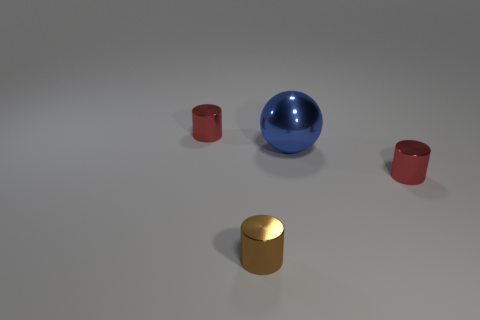Is there any other thing that is the same size as the blue metal thing?
Offer a very short reply. No. There is a blue thing behind the small shiny cylinder right of the brown thing; what is its size?
Make the answer very short. Large. Are there any tiny red shiny cylinders right of the large blue metal thing?
Your answer should be compact. Yes. Are there an equal number of red metal objects to the right of the large blue metallic thing and large blue shiny objects?
Offer a very short reply. Yes. What is the brown thing made of?
Your answer should be very brief. Metal. There is a thing that is both on the right side of the brown cylinder and in front of the big blue metallic ball; what color is it?
Make the answer very short. Red. Are there an equal number of red metal objects on the right side of the tiny brown shiny thing and brown objects in front of the large blue thing?
Offer a terse response. Yes. There is another large object that is made of the same material as the brown object; what color is it?
Keep it short and to the point. Blue. There is a red thing that is right of the tiny red cylinder behind the metal ball; are there any small brown cylinders behind it?
Provide a short and direct response. No. What is the shape of the tiny brown thing that is the same material as the ball?
Your answer should be compact. Cylinder. 